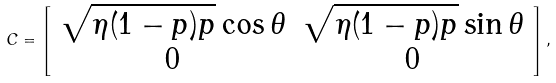Convert formula to latex. <formula><loc_0><loc_0><loc_500><loc_500>C = \left [ \begin{array} { c c } \sqrt { \eta ( 1 - p ) p } \cos \theta & \sqrt { \eta ( 1 - p ) p } \sin \theta \\ 0 & 0 \end{array} \right ] ,</formula> 